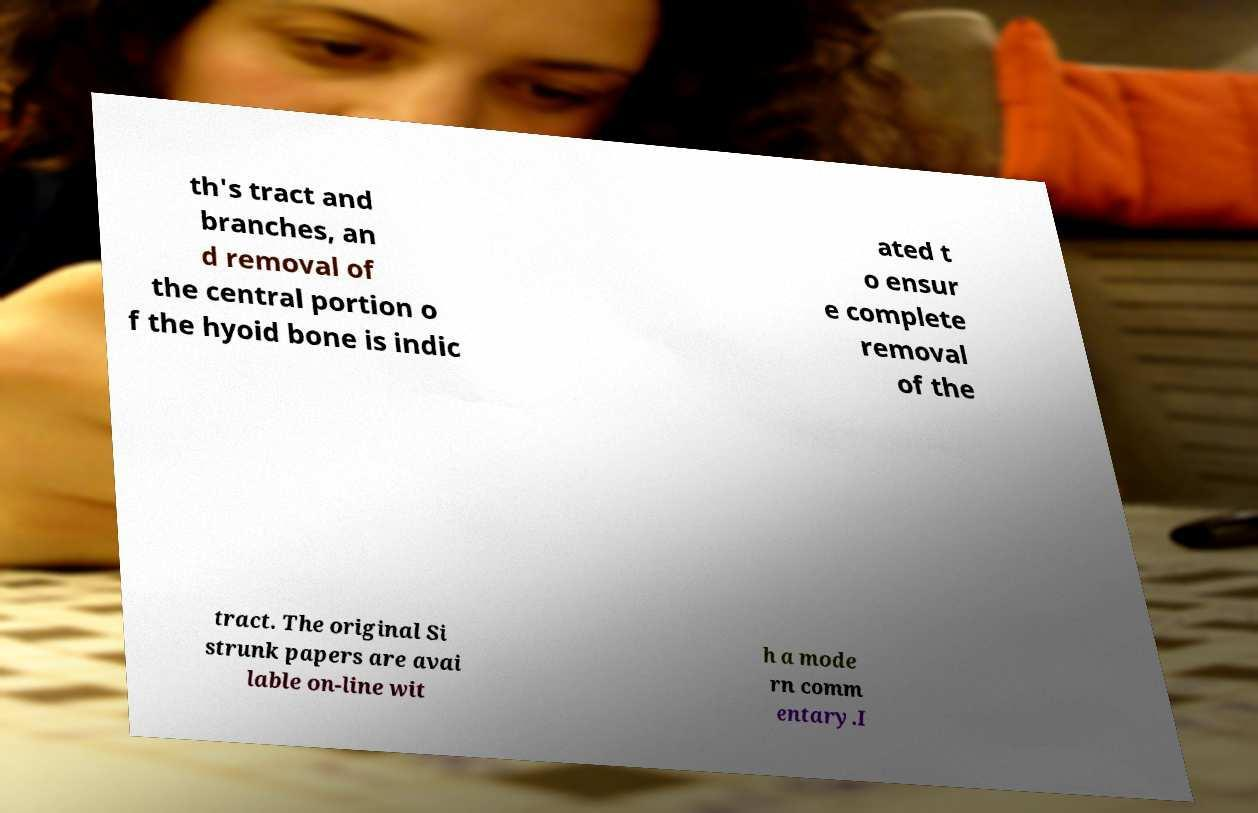Can you read and provide the text displayed in the image?This photo seems to have some interesting text. Can you extract and type it out for me? th's tract and branches, an d removal of the central portion o f the hyoid bone is indic ated t o ensur e complete removal of the tract. The original Si strunk papers are avai lable on-line wit h a mode rn comm entary.I 